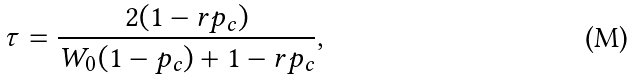<formula> <loc_0><loc_0><loc_500><loc_500>\tau = \frac { 2 ( 1 - r p _ { c } ) } { W _ { 0 } ( 1 - p _ { c } ) + 1 - r p _ { c } } ,</formula> 